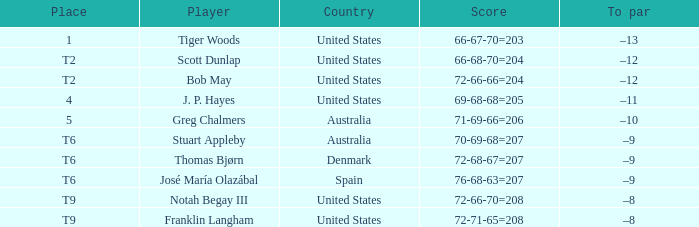What country is player thomas bjørn from? Denmark. Parse the full table. {'header': ['Place', 'Player', 'Country', 'Score', 'To par'], 'rows': [['1', 'Tiger Woods', 'United States', '66-67-70=203', '–13'], ['T2', 'Scott Dunlap', 'United States', '66-68-70=204', '–12'], ['T2', 'Bob May', 'United States', '72-66-66=204', '–12'], ['4', 'J. P. Hayes', 'United States', '69-68-68=205', '–11'], ['5', 'Greg Chalmers', 'Australia', '71-69-66=206', '–10'], ['T6', 'Stuart Appleby', 'Australia', '70-69-68=207', '–9'], ['T6', 'Thomas Bjørn', 'Denmark', '72-68-67=207', '–9'], ['T6', 'José María Olazábal', 'Spain', '76-68-63=207', '–9'], ['T9', 'Notah Begay III', 'United States', '72-66-70=208', '–8'], ['T9', 'Franklin Langham', 'United States', '72-71-65=208', '–8']]} 